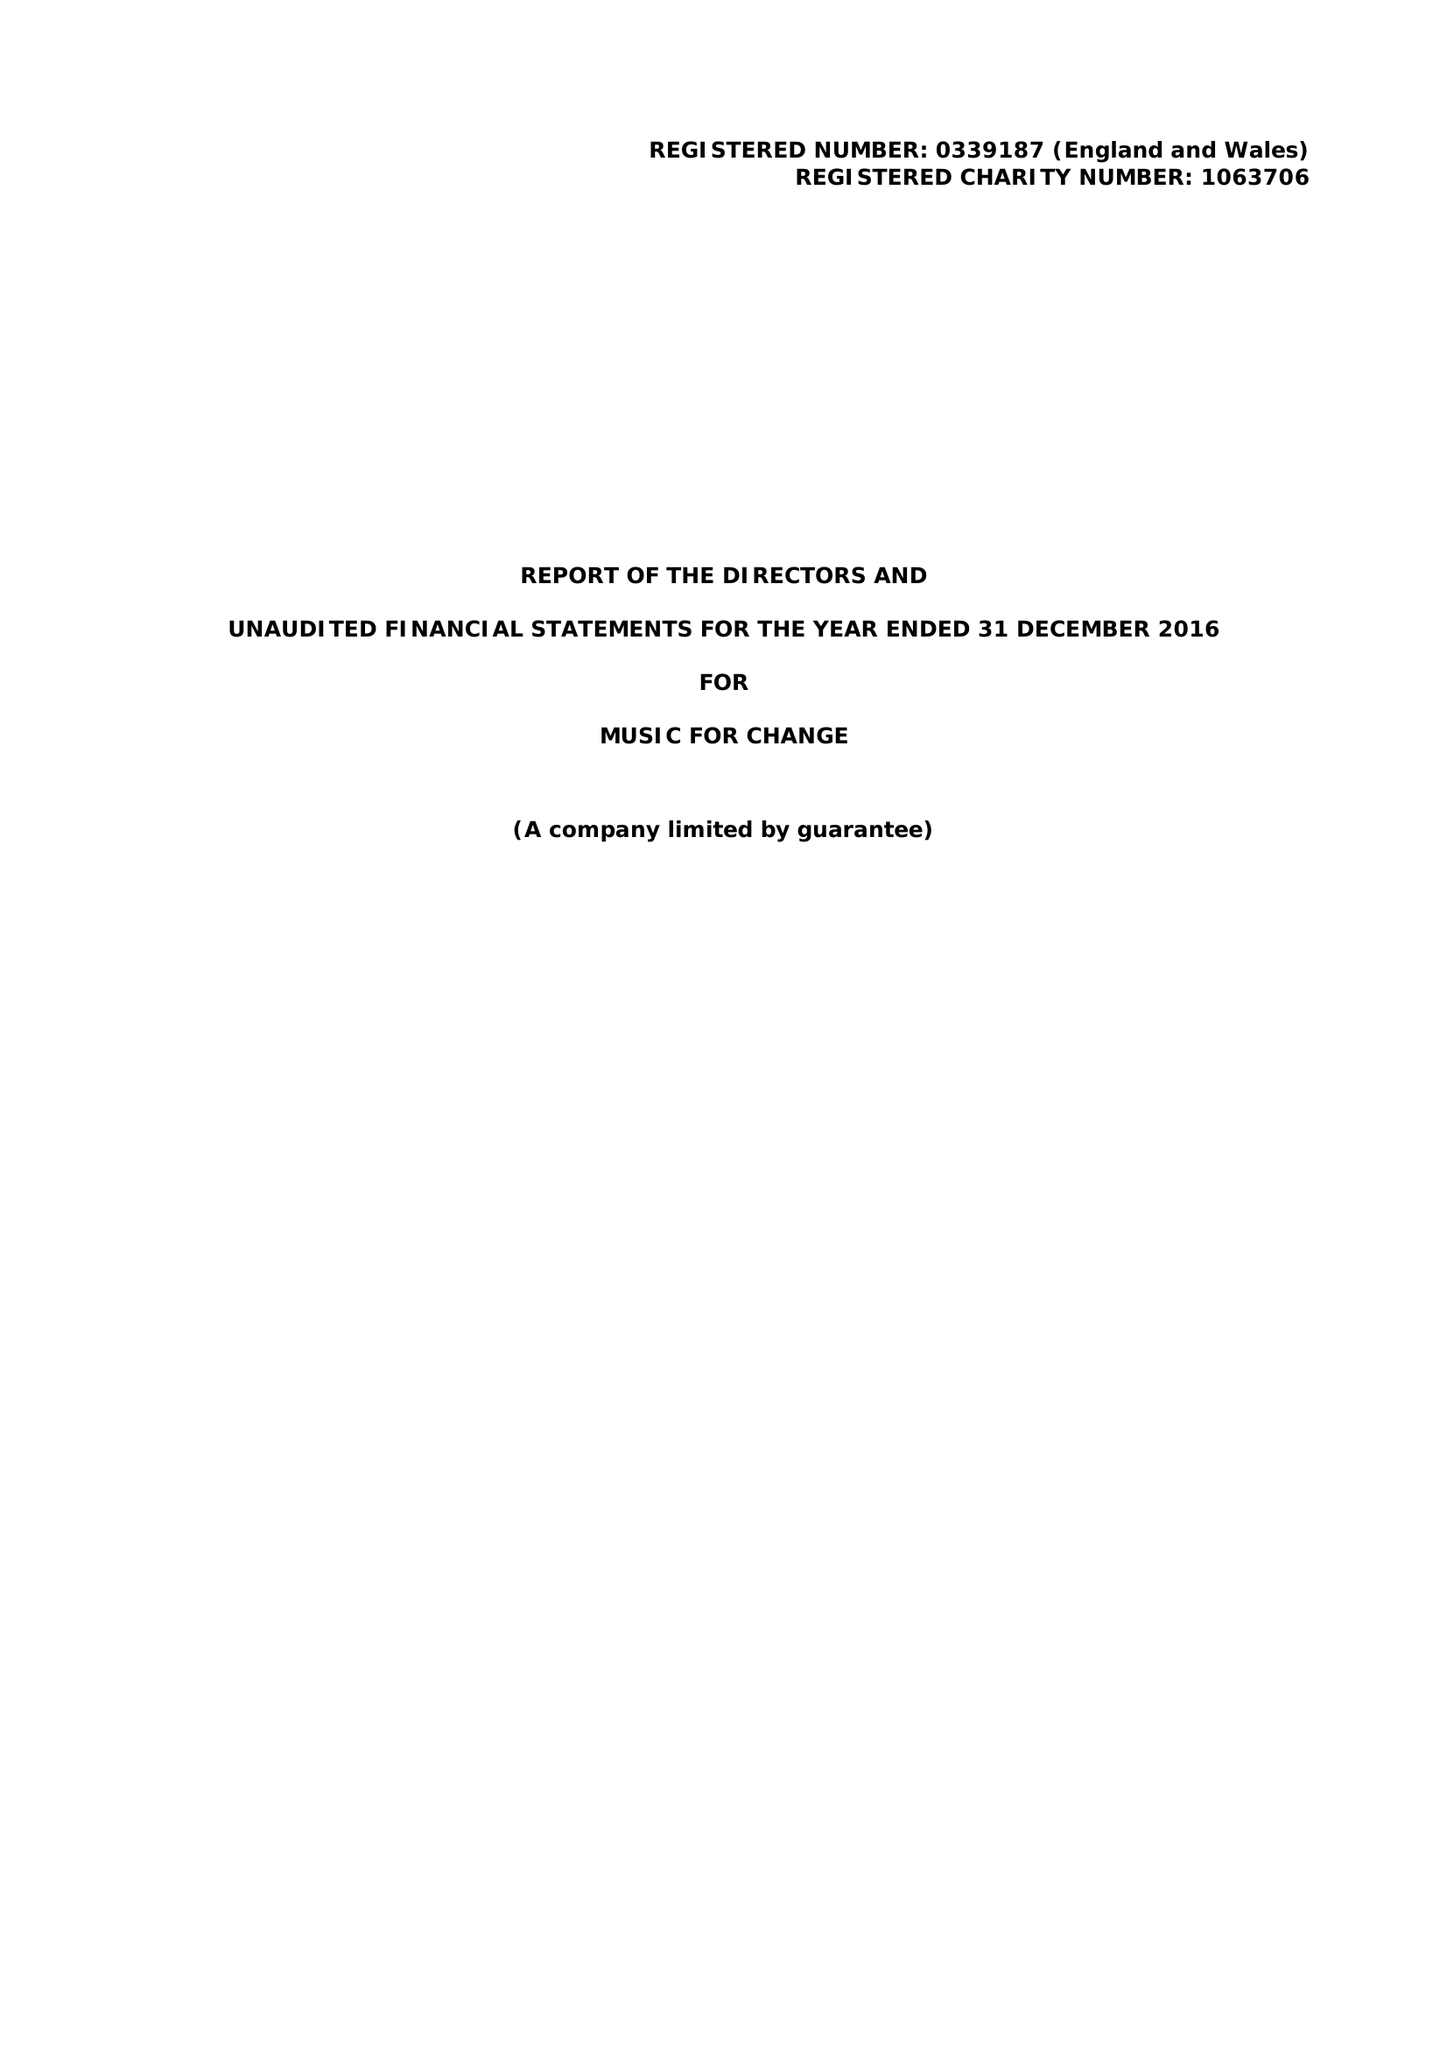What is the value for the charity_name?
Answer the question using a single word or phrase. Music For Change 